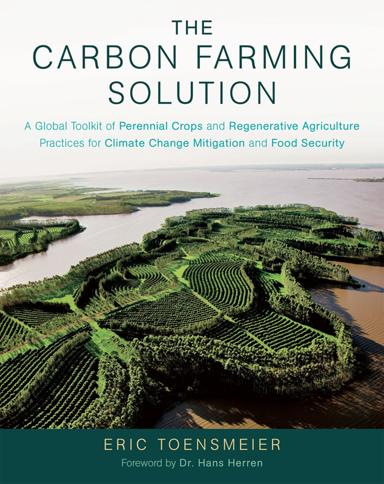Can you describe the type of landscapes shown on the cover of the book and explain why they might be relevant to the book's themes? The cover features an aerial view of intricately structured, verdant agricultural landscapes, specifically showcasing contour farming and possibly agroforestry systems. These practices minimize erosion and maximize water usage efficiency, reflecting the book's focus on sustainable and regenerative farming methods crucial for climate mitigation and food security. 